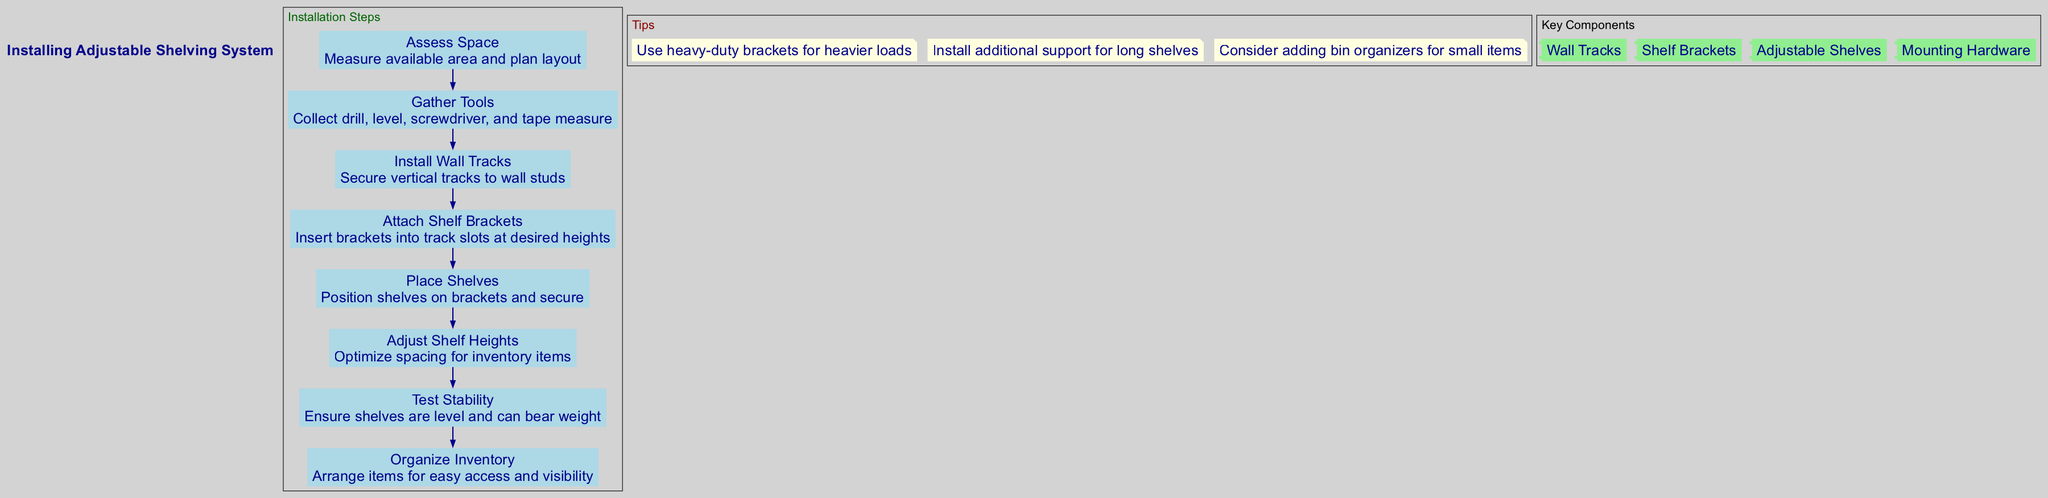What is the first step in the installation process? The diagram presents a sequence of steps for installation. The first step listed is "Assess Space", which is the starting point for the entire installation process.
Answer: Assess Space How many tips are provided in the diagram? The diagram contains a section labeled 'Tips', where specific guidance is offered. Counting the tips listed reveals that there are three individual tips provided.
Answer: 3 What tool is mentioned as necessary for gathering in the second step? The second step emphasizes the need to "Gather Tools." Among the tools listed, "drill" is explicitly mentioned as a necessary item, which is crucial for the installation process.
Answer: drill What component is used for securing shelves? The key components section outlines various elements required for the shelving system. One of the components specifically designed for securing shelves is "Shelf Brackets."
Answer: Shelf Brackets In which step are the shelf heights adjusted? When examining the steps, the description for the fifth step mentions adjusting shelf heights to optimize the spacing for inventory items, indicating that this is where shelf height adjustments are made.
Answer: Adjust Shelf Heights What color is the background of the diagram? The background color of the entire diagram is specified in the attributes as "light gray," which serves as the backdrop for the information presented.
Answer: light gray Which component requires additional support for long shelves according to the tips? One of the tips suggests that "additional support for long shelves" is necessary, implying that the "Shelf Brackets" should be supplemented with extra support to ensure stability.
Answer: Shelf Brackets What is the last step in the installation process? Looking through the steps in the diagram, the final step during the installation sequence is "Organize Inventory," indicating that this is the concluding action to optimize shelf use.
Answer: Organize Inventory 